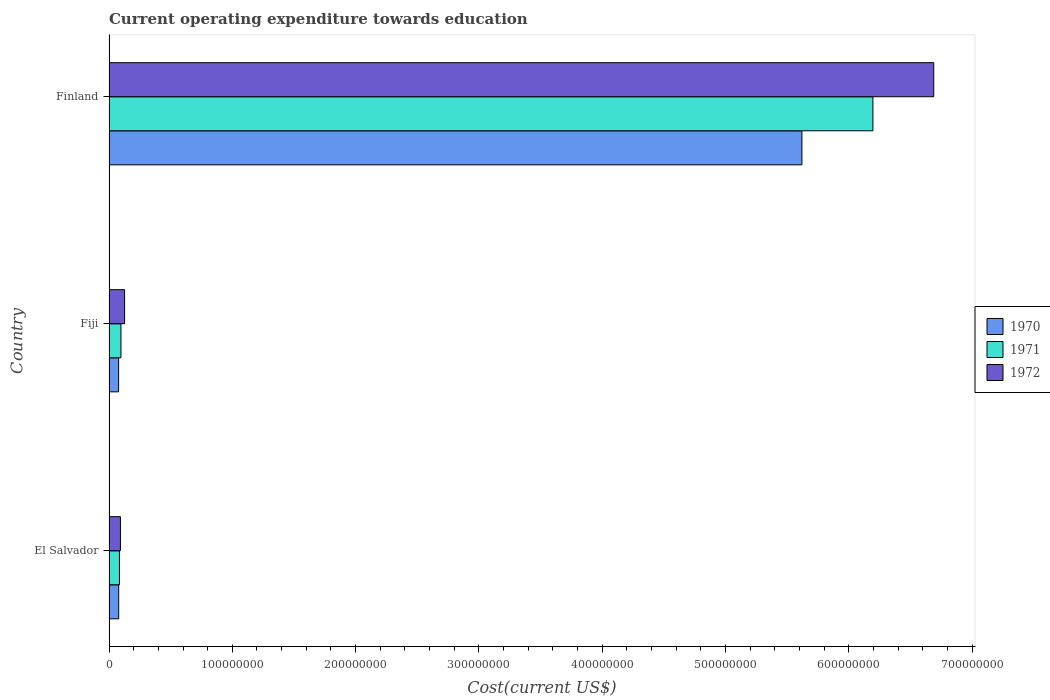Are the number of bars per tick equal to the number of legend labels?
Your answer should be very brief. Yes. Are the number of bars on each tick of the Y-axis equal?
Your answer should be very brief. Yes. How many bars are there on the 3rd tick from the top?
Your answer should be compact. 3. What is the label of the 3rd group of bars from the top?
Make the answer very short. El Salvador. What is the expenditure towards education in 1972 in Finland?
Keep it short and to the point. 6.69e+08. Across all countries, what is the maximum expenditure towards education in 1971?
Provide a succinct answer. 6.20e+08. Across all countries, what is the minimum expenditure towards education in 1970?
Keep it short and to the point. 7.79e+06. In which country was the expenditure towards education in 1970 minimum?
Offer a very short reply. Fiji. What is the total expenditure towards education in 1972 in the graph?
Make the answer very short. 6.91e+08. What is the difference between the expenditure towards education in 1970 in Fiji and that in Finland?
Provide a succinct answer. -5.54e+08. What is the difference between the expenditure towards education in 1972 in Fiji and the expenditure towards education in 1970 in Finland?
Your answer should be compact. -5.49e+08. What is the average expenditure towards education in 1970 per country?
Offer a very short reply. 1.93e+08. What is the difference between the expenditure towards education in 1971 and expenditure towards education in 1970 in Finland?
Ensure brevity in your answer.  5.76e+07. What is the ratio of the expenditure towards education in 1970 in Fiji to that in Finland?
Provide a short and direct response. 0.01. Is the difference between the expenditure towards education in 1971 in El Salvador and Finland greater than the difference between the expenditure towards education in 1970 in El Salvador and Finland?
Offer a very short reply. No. What is the difference between the highest and the second highest expenditure towards education in 1972?
Your answer should be very brief. 6.56e+08. What is the difference between the highest and the lowest expenditure towards education in 1971?
Your answer should be very brief. 6.11e+08. In how many countries, is the expenditure towards education in 1972 greater than the average expenditure towards education in 1972 taken over all countries?
Offer a terse response. 1. Is the sum of the expenditure towards education in 1970 in Fiji and Finland greater than the maximum expenditure towards education in 1972 across all countries?
Ensure brevity in your answer.  No. Is it the case that in every country, the sum of the expenditure towards education in 1972 and expenditure towards education in 1971 is greater than the expenditure towards education in 1970?
Make the answer very short. Yes. Are all the bars in the graph horizontal?
Ensure brevity in your answer.  Yes. What is the difference between two consecutive major ticks on the X-axis?
Ensure brevity in your answer.  1.00e+08. Are the values on the major ticks of X-axis written in scientific E-notation?
Offer a terse response. No. Does the graph contain grids?
Give a very brief answer. No. Where does the legend appear in the graph?
Your answer should be very brief. Center right. How are the legend labels stacked?
Ensure brevity in your answer.  Vertical. What is the title of the graph?
Your answer should be compact. Current operating expenditure towards education. What is the label or title of the X-axis?
Your answer should be compact. Cost(current US$). What is the Cost(current US$) of 1970 in El Salvador?
Offer a very short reply. 7.86e+06. What is the Cost(current US$) of 1971 in El Salvador?
Provide a short and direct response. 8.46e+06. What is the Cost(current US$) of 1972 in El Salvador?
Offer a terse response. 9.26e+06. What is the Cost(current US$) of 1970 in Fiji?
Your answer should be compact. 7.79e+06. What is the Cost(current US$) of 1971 in Fiji?
Your answer should be very brief. 9.67e+06. What is the Cost(current US$) of 1972 in Fiji?
Make the answer very short. 1.26e+07. What is the Cost(current US$) of 1970 in Finland?
Your response must be concise. 5.62e+08. What is the Cost(current US$) of 1971 in Finland?
Your answer should be compact. 6.20e+08. What is the Cost(current US$) of 1972 in Finland?
Your answer should be compact. 6.69e+08. Across all countries, what is the maximum Cost(current US$) of 1970?
Provide a short and direct response. 5.62e+08. Across all countries, what is the maximum Cost(current US$) of 1971?
Your answer should be compact. 6.20e+08. Across all countries, what is the maximum Cost(current US$) of 1972?
Provide a short and direct response. 6.69e+08. Across all countries, what is the minimum Cost(current US$) of 1970?
Your answer should be very brief. 7.79e+06. Across all countries, what is the minimum Cost(current US$) of 1971?
Offer a terse response. 8.46e+06. Across all countries, what is the minimum Cost(current US$) of 1972?
Your response must be concise. 9.26e+06. What is the total Cost(current US$) in 1970 in the graph?
Offer a very short reply. 5.78e+08. What is the total Cost(current US$) in 1971 in the graph?
Provide a succinct answer. 6.38e+08. What is the total Cost(current US$) of 1972 in the graph?
Keep it short and to the point. 6.91e+08. What is the difference between the Cost(current US$) in 1970 in El Salvador and that in Fiji?
Provide a short and direct response. 7.56e+04. What is the difference between the Cost(current US$) in 1971 in El Salvador and that in Fiji?
Make the answer very short. -1.21e+06. What is the difference between the Cost(current US$) in 1972 in El Salvador and that in Fiji?
Offer a terse response. -3.37e+06. What is the difference between the Cost(current US$) in 1970 in El Salvador and that in Finland?
Your answer should be very brief. -5.54e+08. What is the difference between the Cost(current US$) of 1971 in El Salvador and that in Finland?
Offer a very short reply. -6.11e+08. What is the difference between the Cost(current US$) of 1972 in El Salvador and that in Finland?
Make the answer very short. -6.60e+08. What is the difference between the Cost(current US$) in 1970 in Fiji and that in Finland?
Provide a short and direct response. -5.54e+08. What is the difference between the Cost(current US$) in 1971 in Fiji and that in Finland?
Keep it short and to the point. -6.10e+08. What is the difference between the Cost(current US$) in 1972 in Fiji and that in Finland?
Make the answer very short. -6.56e+08. What is the difference between the Cost(current US$) in 1970 in El Salvador and the Cost(current US$) in 1971 in Fiji?
Your answer should be very brief. -1.81e+06. What is the difference between the Cost(current US$) of 1970 in El Salvador and the Cost(current US$) of 1972 in Fiji?
Your answer should be compact. -4.76e+06. What is the difference between the Cost(current US$) of 1971 in El Salvador and the Cost(current US$) of 1972 in Fiji?
Make the answer very short. -4.16e+06. What is the difference between the Cost(current US$) in 1970 in El Salvador and the Cost(current US$) in 1971 in Finland?
Your response must be concise. -6.12e+08. What is the difference between the Cost(current US$) of 1970 in El Salvador and the Cost(current US$) of 1972 in Finland?
Offer a very short reply. -6.61e+08. What is the difference between the Cost(current US$) of 1971 in El Salvador and the Cost(current US$) of 1972 in Finland?
Give a very brief answer. -6.60e+08. What is the difference between the Cost(current US$) of 1970 in Fiji and the Cost(current US$) of 1971 in Finland?
Keep it short and to the point. -6.12e+08. What is the difference between the Cost(current US$) of 1970 in Fiji and the Cost(current US$) of 1972 in Finland?
Make the answer very short. -6.61e+08. What is the difference between the Cost(current US$) in 1971 in Fiji and the Cost(current US$) in 1972 in Finland?
Make the answer very short. -6.59e+08. What is the average Cost(current US$) in 1970 per country?
Your answer should be compact. 1.93e+08. What is the average Cost(current US$) in 1971 per country?
Keep it short and to the point. 2.13e+08. What is the average Cost(current US$) of 1972 per country?
Your response must be concise. 2.30e+08. What is the difference between the Cost(current US$) in 1970 and Cost(current US$) in 1971 in El Salvador?
Keep it short and to the point. -6.00e+05. What is the difference between the Cost(current US$) of 1970 and Cost(current US$) of 1972 in El Salvador?
Offer a very short reply. -1.39e+06. What is the difference between the Cost(current US$) of 1971 and Cost(current US$) of 1972 in El Salvador?
Offer a terse response. -7.94e+05. What is the difference between the Cost(current US$) of 1970 and Cost(current US$) of 1971 in Fiji?
Make the answer very short. -1.89e+06. What is the difference between the Cost(current US$) in 1970 and Cost(current US$) in 1972 in Fiji?
Give a very brief answer. -4.84e+06. What is the difference between the Cost(current US$) of 1971 and Cost(current US$) of 1972 in Fiji?
Offer a very short reply. -2.95e+06. What is the difference between the Cost(current US$) in 1970 and Cost(current US$) in 1971 in Finland?
Provide a succinct answer. -5.76e+07. What is the difference between the Cost(current US$) in 1970 and Cost(current US$) in 1972 in Finland?
Provide a short and direct response. -1.07e+08. What is the difference between the Cost(current US$) of 1971 and Cost(current US$) of 1972 in Finland?
Provide a succinct answer. -4.93e+07. What is the ratio of the Cost(current US$) in 1970 in El Salvador to that in Fiji?
Offer a terse response. 1.01. What is the ratio of the Cost(current US$) in 1971 in El Salvador to that in Fiji?
Provide a succinct answer. 0.87. What is the ratio of the Cost(current US$) of 1972 in El Salvador to that in Fiji?
Give a very brief answer. 0.73. What is the ratio of the Cost(current US$) of 1970 in El Salvador to that in Finland?
Your answer should be very brief. 0.01. What is the ratio of the Cost(current US$) of 1971 in El Salvador to that in Finland?
Provide a short and direct response. 0.01. What is the ratio of the Cost(current US$) in 1972 in El Salvador to that in Finland?
Make the answer very short. 0.01. What is the ratio of the Cost(current US$) of 1970 in Fiji to that in Finland?
Provide a succinct answer. 0.01. What is the ratio of the Cost(current US$) of 1971 in Fiji to that in Finland?
Your answer should be very brief. 0.02. What is the ratio of the Cost(current US$) of 1972 in Fiji to that in Finland?
Your answer should be very brief. 0.02. What is the difference between the highest and the second highest Cost(current US$) in 1970?
Your answer should be compact. 5.54e+08. What is the difference between the highest and the second highest Cost(current US$) in 1971?
Your answer should be very brief. 6.10e+08. What is the difference between the highest and the second highest Cost(current US$) of 1972?
Make the answer very short. 6.56e+08. What is the difference between the highest and the lowest Cost(current US$) in 1970?
Offer a very short reply. 5.54e+08. What is the difference between the highest and the lowest Cost(current US$) of 1971?
Your response must be concise. 6.11e+08. What is the difference between the highest and the lowest Cost(current US$) of 1972?
Ensure brevity in your answer.  6.60e+08. 